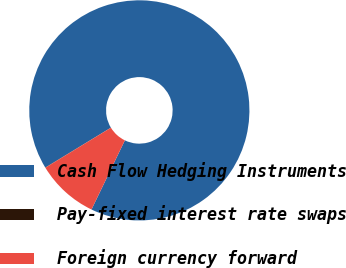Convert chart to OTSL. <chart><loc_0><loc_0><loc_500><loc_500><pie_chart><fcel>Cash Flow Hedging Instruments<fcel>Pay-fixed interest rate swaps<fcel>Foreign currency forward<nl><fcel>90.84%<fcel>0.04%<fcel>9.12%<nl></chart> 